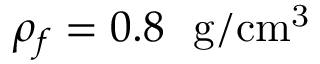<formula> <loc_0><loc_0><loc_500><loc_500>\rho _ { f } = 0 . 8 g / c m ^ { 3 }</formula> 